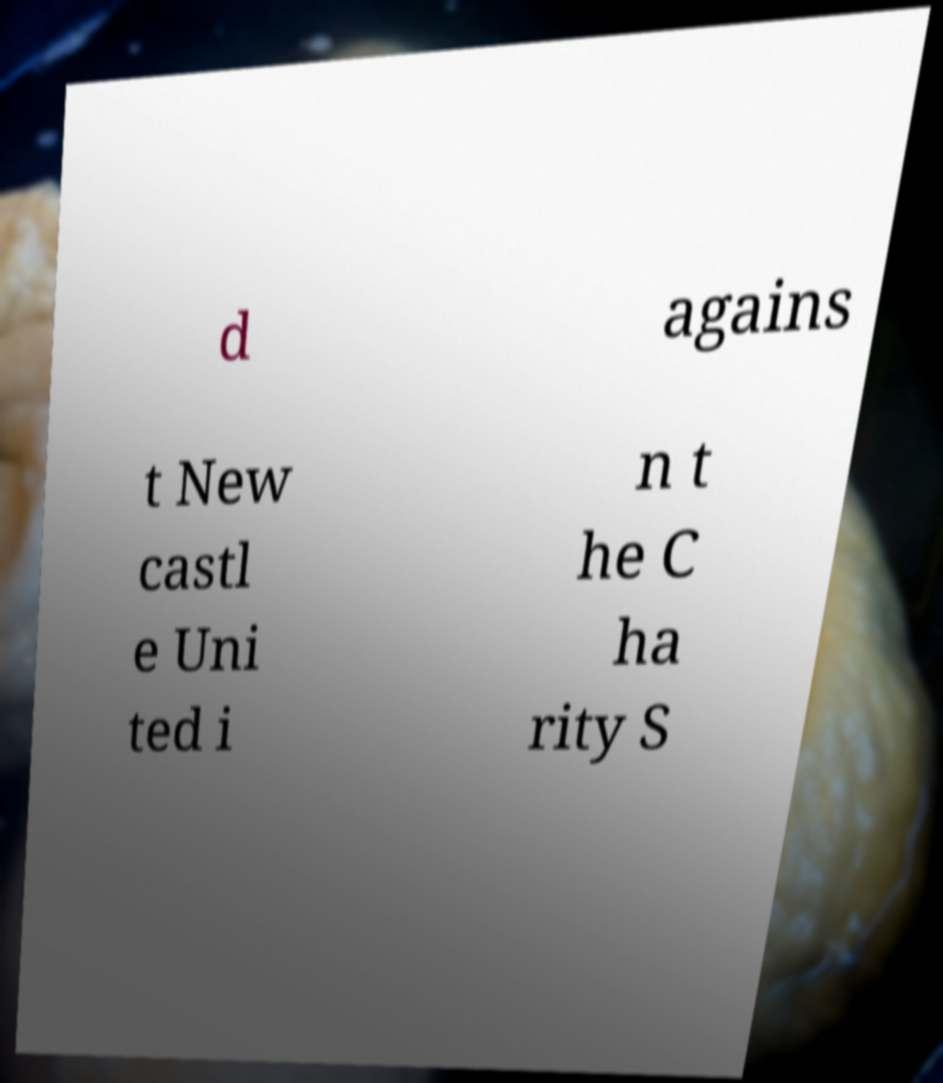Could you assist in decoding the text presented in this image and type it out clearly? d agains t New castl e Uni ted i n t he C ha rity S 